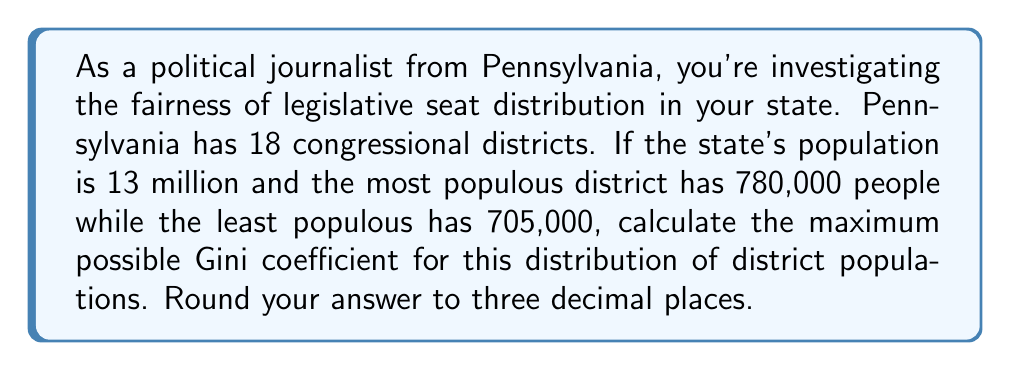Give your solution to this math problem. To solve this problem, we'll follow these steps:

1) The Gini coefficient measures inequality in a distribution. It ranges from 0 (perfect equality) to 1 (maximum inequality).

2) In this case, we're given:
   - Total districts: $n = 18$
   - Total population: $N = 13,000,000$
   - Most populous district: $x_{max} = 780,000$
   - Least populous district: $x_{min} = 705,000$

3) The Gini coefficient is maximized when all districts except one have the minimum population, and one district has the remaining population.

4) Calculate the total population in the 17 smallest districts:
   $17 \times 705,000 = 11,985,000$

5) The largest district would then have:
   $13,000,000 - 11,985,000 = 1,015,000$ people

6) The Gini coefficient formula for discrete data is:

   $$G = \frac{\sum_{i=1}^n \sum_{j=1}^n |x_i - x_j|}{2n^2\bar{x}}$$

   where $\bar{x}$ is the mean population per district.

7) In this case:
   $\sum_{i=1}^n \sum_{j=1}^n |x_i - x_j| = 2 \times 17 \times (1,015,000 - 705,000) = 10,540,000$

8) The mean population per district:
   $\bar{x} = 13,000,000 / 18 = 722,222.22$

9) Plugging into the formula:

   $$G = \frac{10,540,000}{2 \times 18^2 \times 722,222.22} = 0.2257$$

10) Rounding to three decimal places: 0.226
Answer: 0.226 